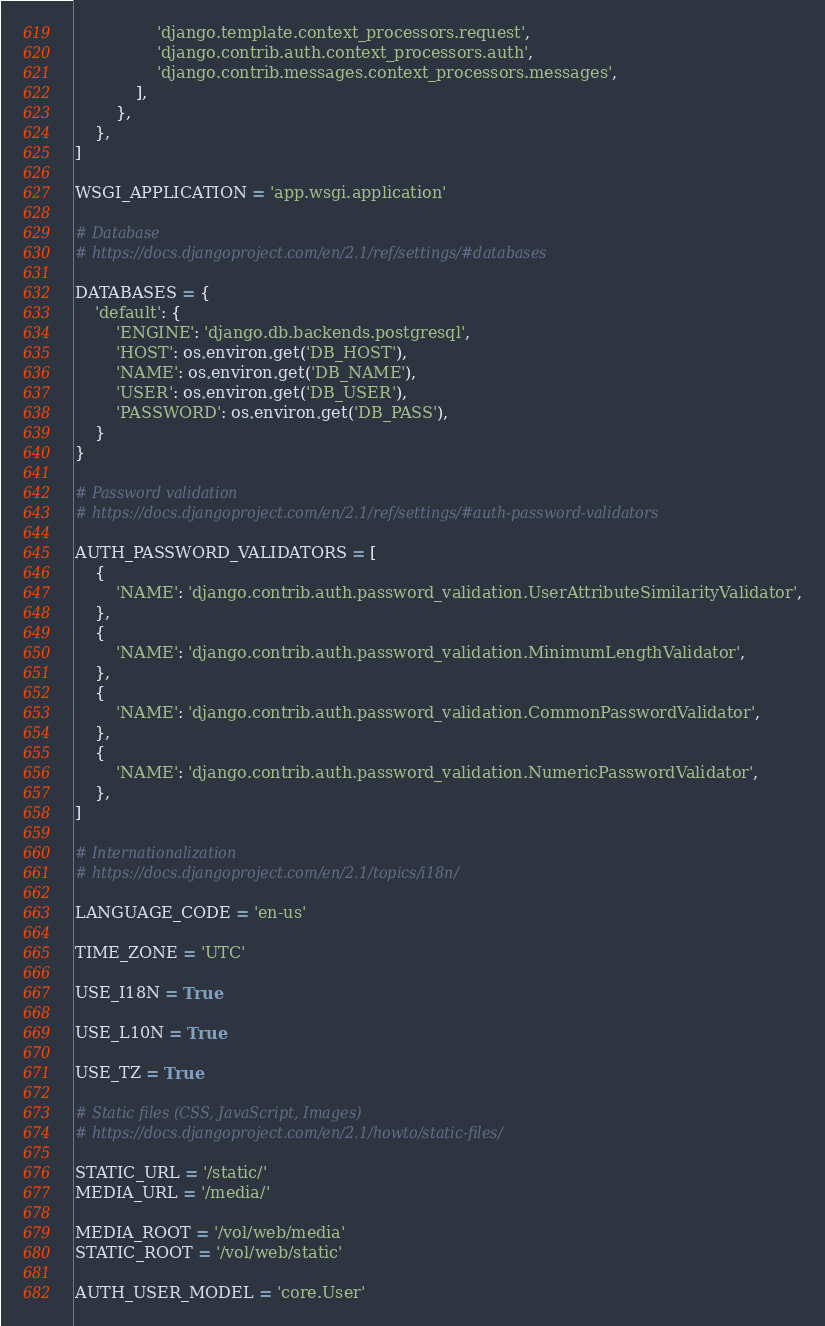Convert code to text. <code><loc_0><loc_0><loc_500><loc_500><_Python_>                'django.template.context_processors.request',
                'django.contrib.auth.context_processors.auth',
                'django.contrib.messages.context_processors.messages',
            ],
        },
    },
]

WSGI_APPLICATION = 'app.wsgi.application'

# Database
# https://docs.djangoproject.com/en/2.1/ref/settings/#databases

DATABASES = {
    'default': {
        'ENGINE': 'django.db.backends.postgresql',
        'HOST': os.environ.get('DB_HOST'),
        'NAME': os.environ.get('DB_NAME'),
        'USER': os.environ.get('DB_USER'),
        'PASSWORD': os.environ.get('DB_PASS'),
    }
}

# Password validation
# https://docs.djangoproject.com/en/2.1/ref/settings/#auth-password-validators

AUTH_PASSWORD_VALIDATORS = [
    {
        'NAME': 'django.contrib.auth.password_validation.UserAttributeSimilarityValidator',
    },
    {
        'NAME': 'django.contrib.auth.password_validation.MinimumLengthValidator',
    },
    {
        'NAME': 'django.contrib.auth.password_validation.CommonPasswordValidator',
    },
    {
        'NAME': 'django.contrib.auth.password_validation.NumericPasswordValidator',
    },
]

# Internationalization
# https://docs.djangoproject.com/en/2.1/topics/i18n/

LANGUAGE_CODE = 'en-us'

TIME_ZONE = 'UTC'

USE_I18N = True

USE_L10N = True

USE_TZ = True

# Static files (CSS, JavaScript, Images)
# https://docs.djangoproject.com/en/2.1/howto/static-files/

STATIC_URL = '/static/'
MEDIA_URL = '/media/'

MEDIA_ROOT = '/vol/web/media'
STATIC_ROOT = '/vol/web/static'

AUTH_USER_MODEL = 'core.User'
</code> 